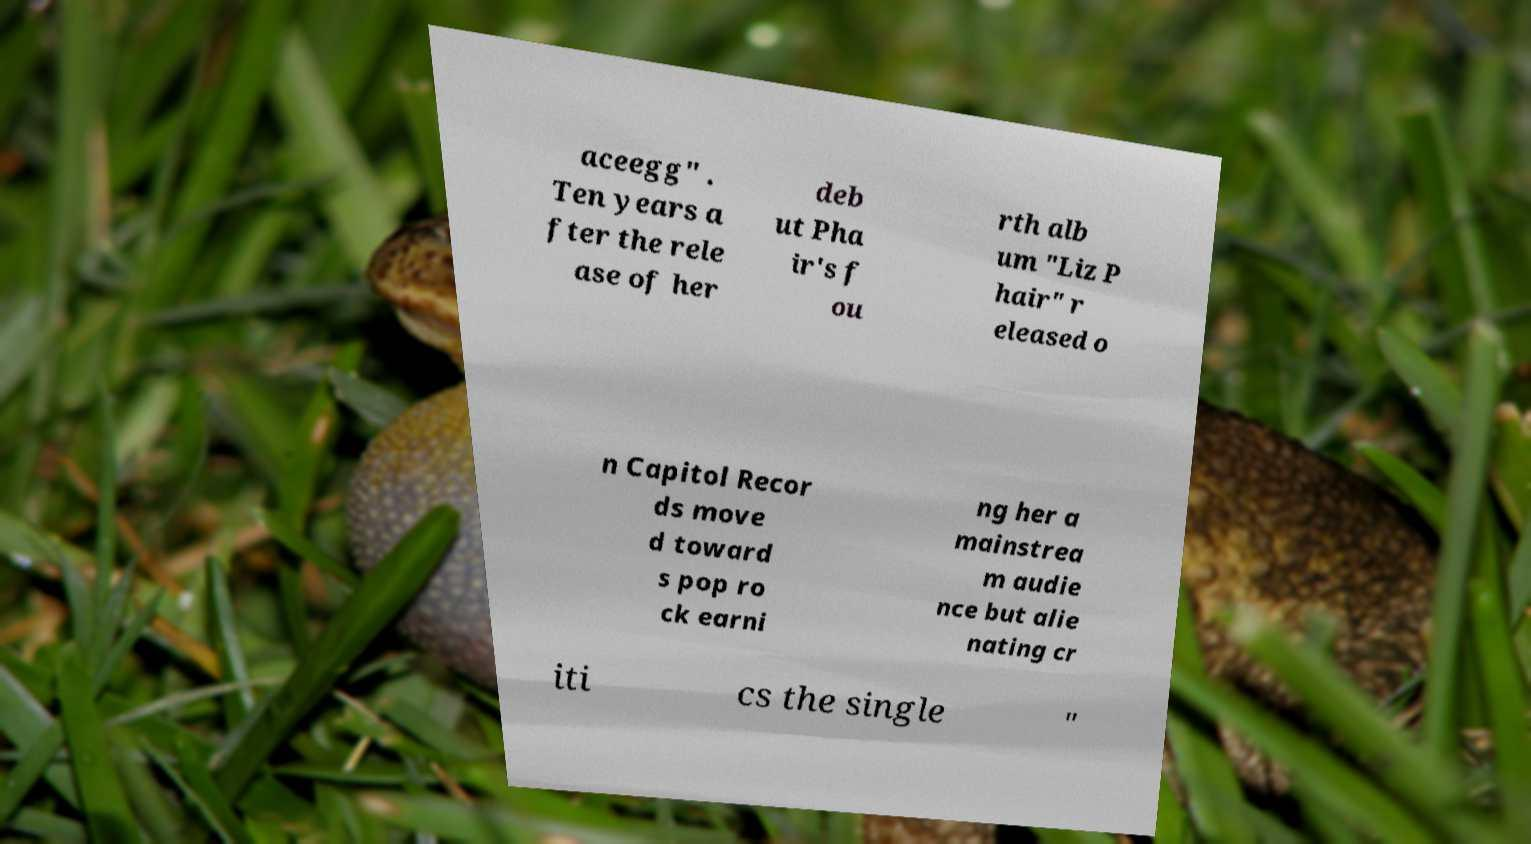What messages or text are displayed in this image? I need them in a readable, typed format. aceegg" . Ten years a fter the rele ase of her deb ut Pha ir's f ou rth alb um "Liz P hair" r eleased o n Capitol Recor ds move d toward s pop ro ck earni ng her a mainstrea m audie nce but alie nating cr iti cs the single " 